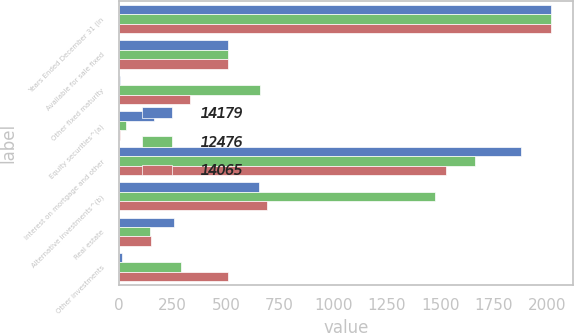Convert chart to OTSL. <chart><loc_0><loc_0><loc_500><loc_500><stacked_bar_chart><ecel><fcel>Years Ended December 31 (in<fcel>Available for sale fixed<fcel>Other fixed maturity<fcel>Equity securities^(a)<fcel>Interest on mortgage and other<fcel>Alternative investments^(b)<fcel>Real estate<fcel>Other investments<nl><fcel>14179<fcel>2018<fcel>509<fcel>7<fcel>162<fcel>1874<fcel>655<fcel>257<fcel>15<nl><fcel>12476<fcel>2017<fcel>509<fcel>660<fcel>34<fcel>1661<fcel>1475<fcel>144<fcel>290<nl><fcel>14065<fcel>2016<fcel>509<fcel>331<fcel>5<fcel>1526<fcel>693<fcel>150<fcel>509<nl></chart> 